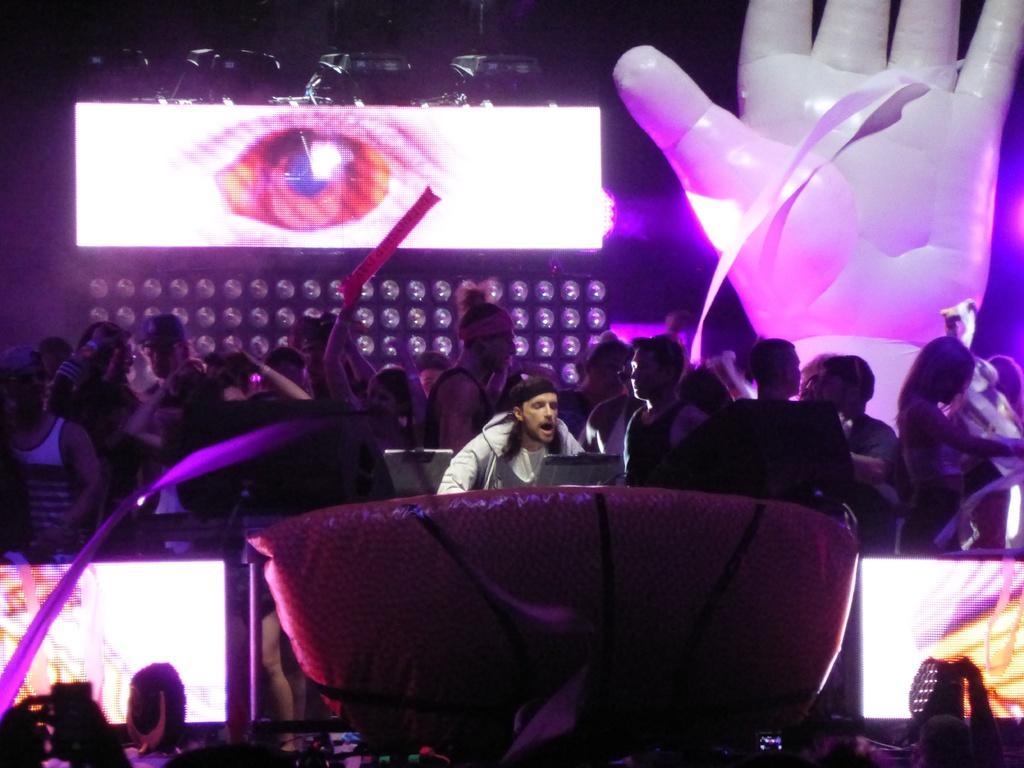Please provide a concise description of this image. In this picture there is a man who is sitting on the chair, beside him there is a table. On that i can see the laptop and other objects. Behind him i can see many peoples were standing. In the top right there is a balloon which designed like a person's hand. In the background i can see the screen, which showing an eye. In the bottom left corner there is a woman who is standing near to the television screen. In the bottom right corner there is a focus light, beside that there is a screen. 